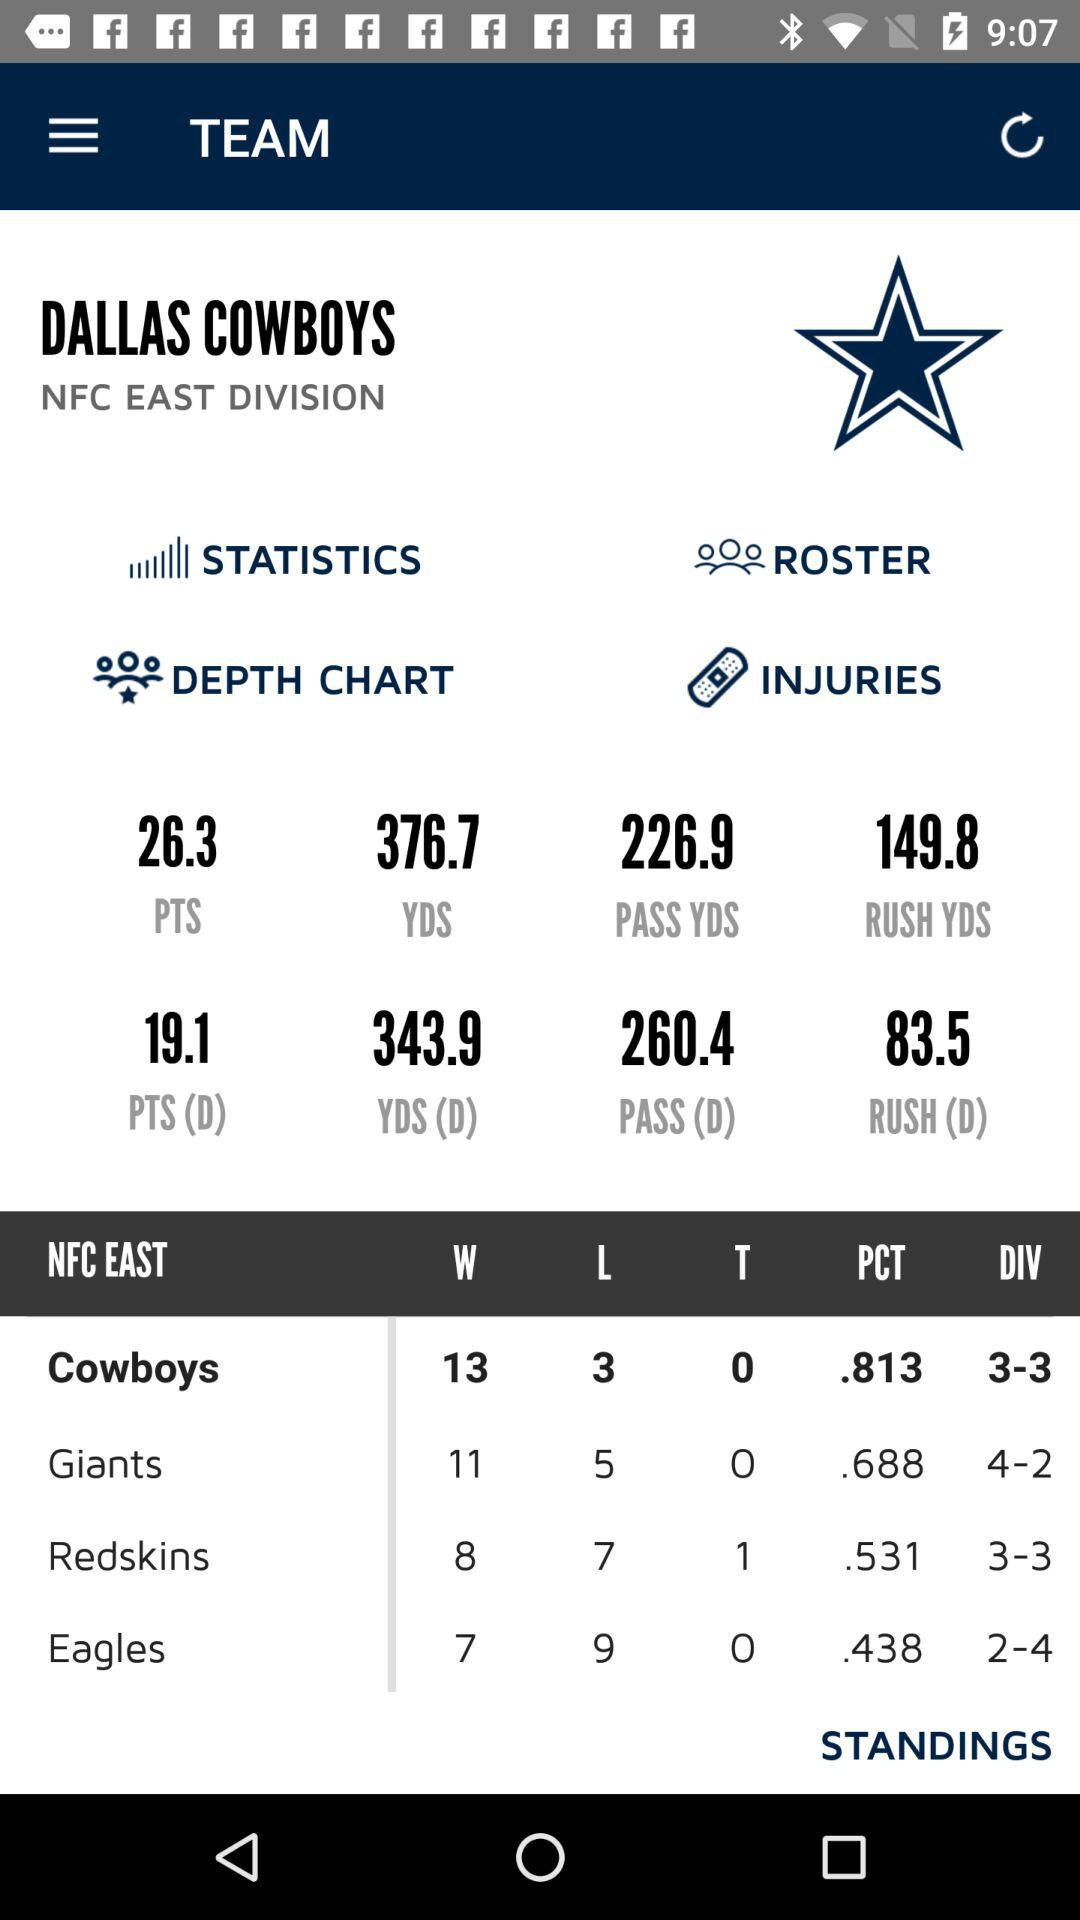Which team has a higher winning percentage, the Cowboys or the Redskins?
Answer the question using a single word or phrase. Cowboys 